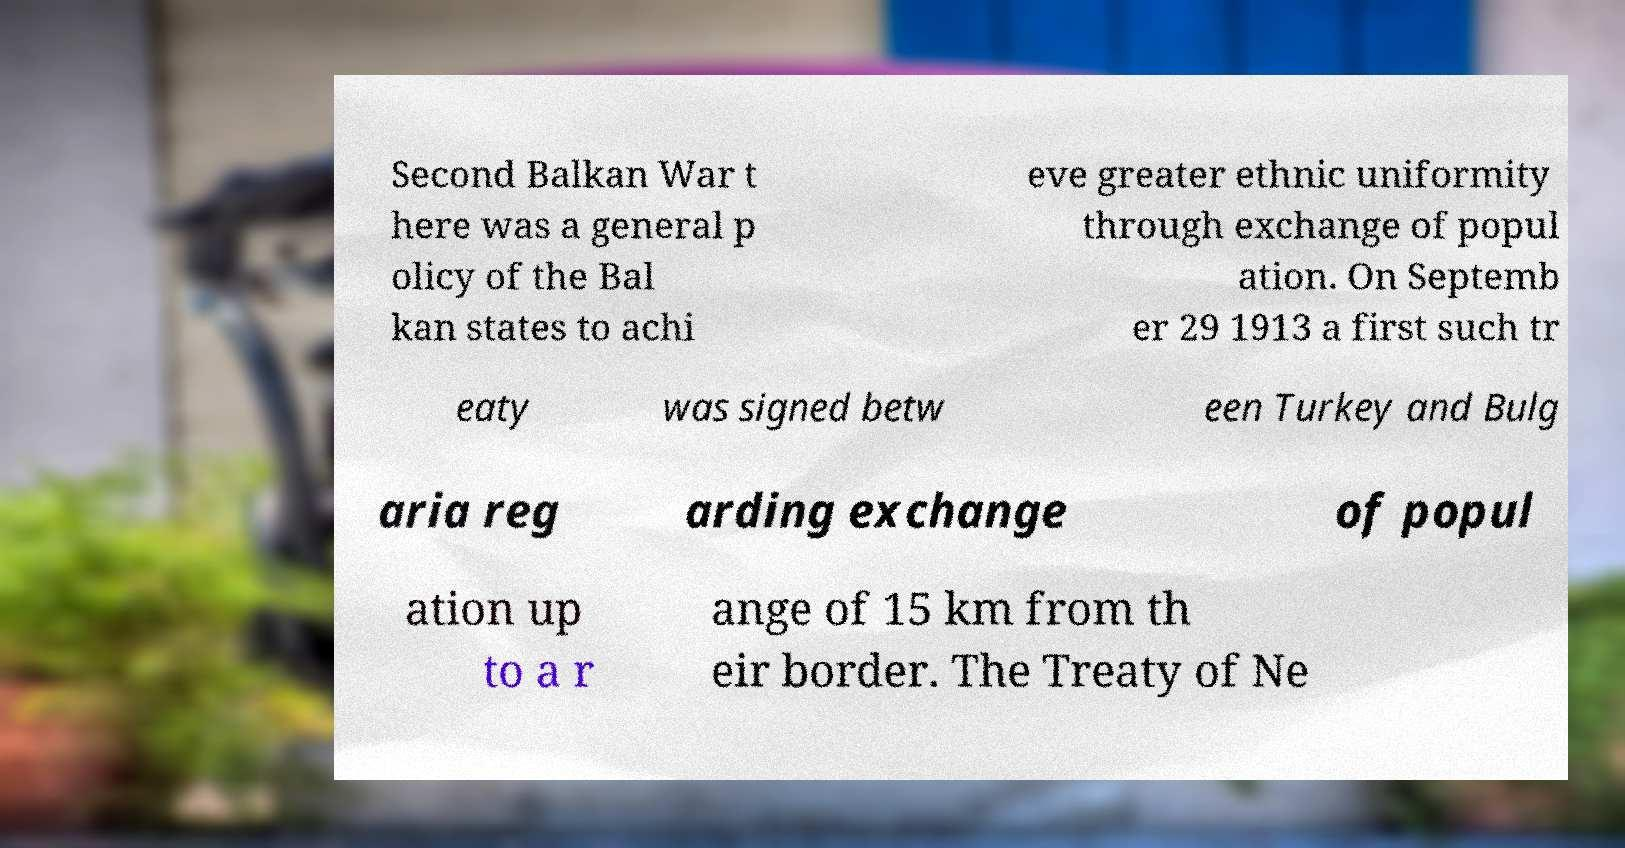I need the written content from this picture converted into text. Can you do that? Second Balkan War t here was a general p olicy of the Bal kan states to achi eve greater ethnic uniformity through exchange of popul ation. On Septemb er 29 1913 a first such tr eaty was signed betw een Turkey and Bulg aria reg arding exchange of popul ation up to a r ange of 15 km from th eir border. The Treaty of Ne 